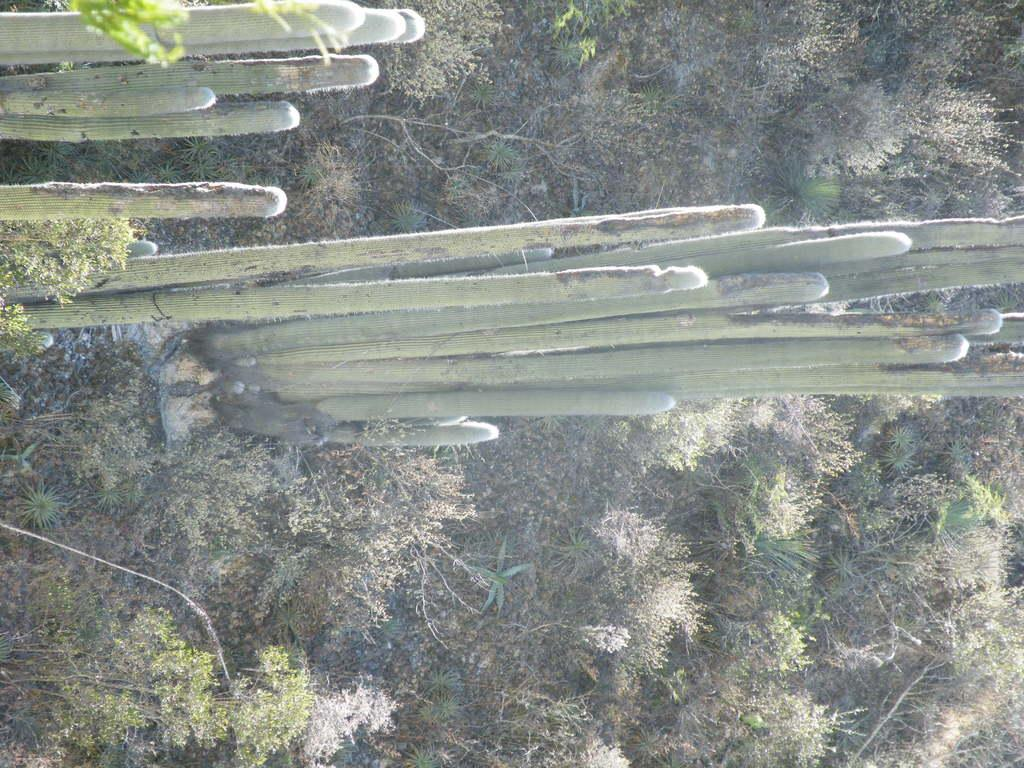What type of plants can be seen on the ground in the image? There are many plants on the ground in the image. Can you identify any specific type of plant among those on the ground? Yes, there are cactus plants in the image. What type of match can be seen in the image? There is no match present in the image. What kind of jewel is being worn by the cactus in the image? There are no jewels or cacti wearing jewels in the image. 